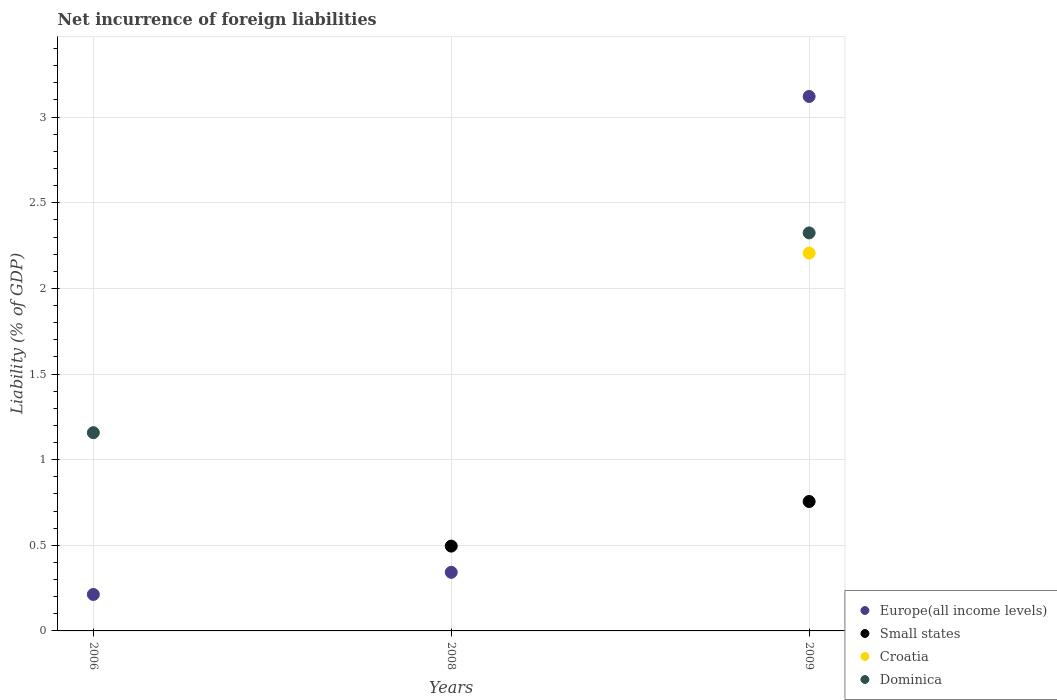How many different coloured dotlines are there?
Offer a terse response. 4. Is the number of dotlines equal to the number of legend labels?
Make the answer very short. No. What is the net incurrence of foreign liabilities in Europe(all income levels) in 2006?
Ensure brevity in your answer.  0.21. Across all years, what is the maximum net incurrence of foreign liabilities in Small states?
Give a very brief answer. 0.76. Across all years, what is the minimum net incurrence of foreign liabilities in Small states?
Keep it short and to the point. 0. What is the total net incurrence of foreign liabilities in Croatia in the graph?
Keep it short and to the point. 2.21. What is the difference between the net incurrence of foreign liabilities in Europe(all income levels) in 2006 and that in 2008?
Your answer should be very brief. -0.13. What is the difference between the net incurrence of foreign liabilities in Europe(all income levels) in 2006 and the net incurrence of foreign liabilities in Small states in 2008?
Make the answer very short. -0.28. What is the average net incurrence of foreign liabilities in Small states per year?
Ensure brevity in your answer.  0.42. In the year 2009, what is the difference between the net incurrence of foreign liabilities in Small states and net incurrence of foreign liabilities in Europe(all income levels)?
Keep it short and to the point. -2.37. In how many years, is the net incurrence of foreign liabilities in Small states greater than 2.7 %?
Your answer should be very brief. 0. What is the ratio of the net incurrence of foreign liabilities in Europe(all income levels) in 2008 to that in 2009?
Offer a very short reply. 0.11. What is the difference between the highest and the second highest net incurrence of foreign liabilities in Europe(all income levels)?
Your answer should be compact. 2.78. What is the difference between the highest and the lowest net incurrence of foreign liabilities in Europe(all income levels)?
Your answer should be very brief. 2.91. Does the net incurrence of foreign liabilities in Croatia monotonically increase over the years?
Your answer should be compact. Yes. Is the net incurrence of foreign liabilities in Dominica strictly less than the net incurrence of foreign liabilities in Europe(all income levels) over the years?
Offer a terse response. No. How many dotlines are there?
Give a very brief answer. 4. How many years are there in the graph?
Make the answer very short. 3. Are the values on the major ticks of Y-axis written in scientific E-notation?
Your answer should be compact. No. Does the graph contain grids?
Your response must be concise. Yes. Where does the legend appear in the graph?
Provide a short and direct response. Bottom right. How are the legend labels stacked?
Your response must be concise. Vertical. What is the title of the graph?
Provide a succinct answer. Net incurrence of foreign liabilities. What is the label or title of the Y-axis?
Give a very brief answer. Liability (% of GDP). What is the Liability (% of GDP) of Europe(all income levels) in 2006?
Provide a short and direct response. 0.21. What is the Liability (% of GDP) of Croatia in 2006?
Provide a short and direct response. 0. What is the Liability (% of GDP) in Dominica in 2006?
Keep it short and to the point. 1.16. What is the Liability (% of GDP) in Europe(all income levels) in 2008?
Provide a succinct answer. 0.34. What is the Liability (% of GDP) of Small states in 2008?
Your answer should be compact. 0.5. What is the Liability (% of GDP) of Europe(all income levels) in 2009?
Your answer should be compact. 3.12. What is the Liability (% of GDP) of Small states in 2009?
Give a very brief answer. 0.76. What is the Liability (% of GDP) in Croatia in 2009?
Provide a short and direct response. 2.21. What is the Liability (% of GDP) in Dominica in 2009?
Make the answer very short. 2.32. Across all years, what is the maximum Liability (% of GDP) of Europe(all income levels)?
Give a very brief answer. 3.12. Across all years, what is the maximum Liability (% of GDP) of Small states?
Offer a terse response. 0.76. Across all years, what is the maximum Liability (% of GDP) of Croatia?
Offer a terse response. 2.21. Across all years, what is the maximum Liability (% of GDP) in Dominica?
Provide a succinct answer. 2.32. Across all years, what is the minimum Liability (% of GDP) in Europe(all income levels)?
Your answer should be compact. 0.21. Across all years, what is the minimum Liability (% of GDP) in Croatia?
Offer a very short reply. 0. Across all years, what is the minimum Liability (% of GDP) of Dominica?
Offer a very short reply. 0. What is the total Liability (% of GDP) in Europe(all income levels) in the graph?
Provide a short and direct response. 3.68. What is the total Liability (% of GDP) in Small states in the graph?
Offer a very short reply. 1.25. What is the total Liability (% of GDP) in Croatia in the graph?
Ensure brevity in your answer.  2.21. What is the total Liability (% of GDP) in Dominica in the graph?
Make the answer very short. 3.48. What is the difference between the Liability (% of GDP) of Europe(all income levels) in 2006 and that in 2008?
Ensure brevity in your answer.  -0.13. What is the difference between the Liability (% of GDP) of Europe(all income levels) in 2006 and that in 2009?
Your answer should be very brief. -2.91. What is the difference between the Liability (% of GDP) of Dominica in 2006 and that in 2009?
Offer a very short reply. -1.17. What is the difference between the Liability (% of GDP) in Europe(all income levels) in 2008 and that in 2009?
Offer a very short reply. -2.78. What is the difference between the Liability (% of GDP) in Small states in 2008 and that in 2009?
Ensure brevity in your answer.  -0.26. What is the difference between the Liability (% of GDP) of Europe(all income levels) in 2006 and the Liability (% of GDP) of Small states in 2008?
Ensure brevity in your answer.  -0.28. What is the difference between the Liability (% of GDP) of Europe(all income levels) in 2006 and the Liability (% of GDP) of Small states in 2009?
Offer a terse response. -0.54. What is the difference between the Liability (% of GDP) of Europe(all income levels) in 2006 and the Liability (% of GDP) of Croatia in 2009?
Keep it short and to the point. -1.99. What is the difference between the Liability (% of GDP) in Europe(all income levels) in 2006 and the Liability (% of GDP) in Dominica in 2009?
Ensure brevity in your answer.  -2.11. What is the difference between the Liability (% of GDP) of Europe(all income levels) in 2008 and the Liability (% of GDP) of Small states in 2009?
Your answer should be compact. -0.41. What is the difference between the Liability (% of GDP) of Europe(all income levels) in 2008 and the Liability (% of GDP) of Croatia in 2009?
Provide a succinct answer. -1.86. What is the difference between the Liability (% of GDP) in Europe(all income levels) in 2008 and the Liability (% of GDP) in Dominica in 2009?
Keep it short and to the point. -1.98. What is the difference between the Liability (% of GDP) in Small states in 2008 and the Liability (% of GDP) in Croatia in 2009?
Your answer should be very brief. -1.71. What is the difference between the Liability (% of GDP) in Small states in 2008 and the Liability (% of GDP) in Dominica in 2009?
Your answer should be very brief. -1.83. What is the average Liability (% of GDP) of Europe(all income levels) per year?
Keep it short and to the point. 1.23. What is the average Liability (% of GDP) in Small states per year?
Ensure brevity in your answer.  0.42. What is the average Liability (% of GDP) in Croatia per year?
Make the answer very short. 0.74. What is the average Liability (% of GDP) in Dominica per year?
Your response must be concise. 1.16. In the year 2006, what is the difference between the Liability (% of GDP) in Europe(all income levels) and Liability (% of GDP) in Dominica?
Your answer should be compact. -0.94. In the year 2008, what is the difference between the Liability (% of GDP) in Europe(all income levels) and Liability (% of GDP) in Small states?
Ensure brevity in your answer.  -0.15. In the year 2009, what is the difference between the Liability (% of GDP) in Europe(all income levels) and Liability (% of GDP) in Small states?
Your answer should be very brief. 2.37. In the year 2009, what is the difference between the Liability (% of GDP) of Europe(all income levels) and Liability (% of GDP) of Croatia?
Keep it short and to the point. 0.91. In the year 2009, what is the difference between the Liability (% of GDP) in Europe(all income levels) and Liability (% of GDP) in Dominica?
Ensure brevity in your answer.  0.8. In the year 2009, what is the difference between the Liability (% of GDP) of Small states and Liability (% of GDP) of Croatia?
Make the answer very short. -1.45. In the year 2009, what is the difference between the Liability (% of GDP) of Small states and Liability (% of GDP) of Dominica?
Provide a succinct answer. -1.57. In the year 2009, what is the difference between the Liability (% of GDP) of Croatia and Liability (% of GDP) of Dominica?
Your response must be concise. -0.12. What is the ratio of the Liability (% of GDP) in Europe(all income levels) in 2006 to that in 2008?
Provide a succinct answer. 0.62. What is the ratio of the Liability (% of GDP) of Europe(all income levels) in 2006 to that in 2009?
Your answer should be very brief. 0.07. What is the ratio of the Liability (% of GDP) of Dominica in 2006 to that in 2009?
Provide a succinct answer. 0.5. What is the ratio of the Liability (% of GDP) of Europe(all income levels) in 2008 to that in 2009?
Give a very brief answer. 0.11. What is the ratio of the Liability (% of GDP) in Small states in 2008 to that in 2009?
Provide a short and direct response. 0.66. What is the difference between the highest and the second highest Liability (% of GDP) in Europe(all income levels)?
Your answer should be compact. 2.78. What is the difference between the highest and the lowest Liability (% of GDP) in Europe(all income levels)?
Provide a succinct answer. 2.91. What is the difference between the highest and the lowest Liability (% of GDP) of Small states?
Offer a terse response. 0.76. What is the difference between the highest and the lowest Liability (% of GDP) of Croatia?
Offer a very short reply. 2.21. What is the difference between the highest and the lowest Liability (% of GDP) in Dominica?
Offer a very short reply. 2.32. 